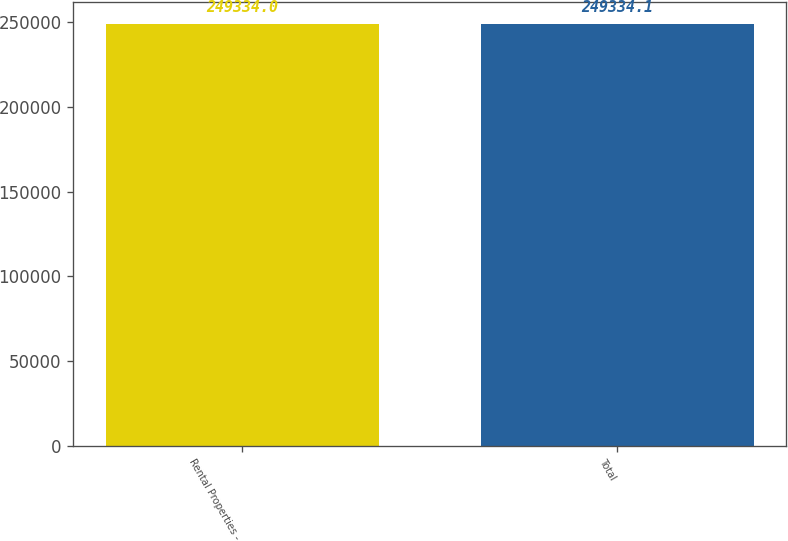Convert chart. <chart><loc_0><loc_0><loc_500><loc_500><bar_chart><fcel>Rental Properties -<fcel>Total<nl><fcel>249334<fcel>249334<nl></chart> 